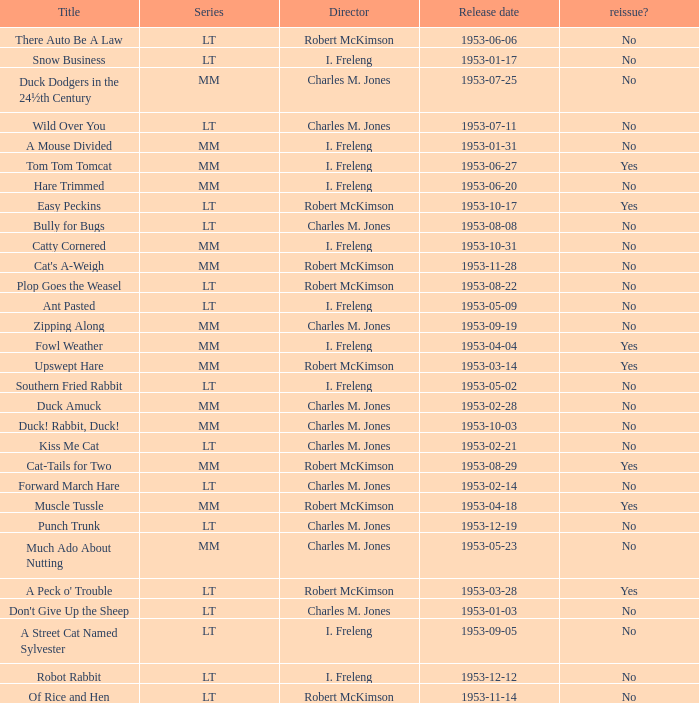What's the release date of Forward March Hare? 1953-02-14. 